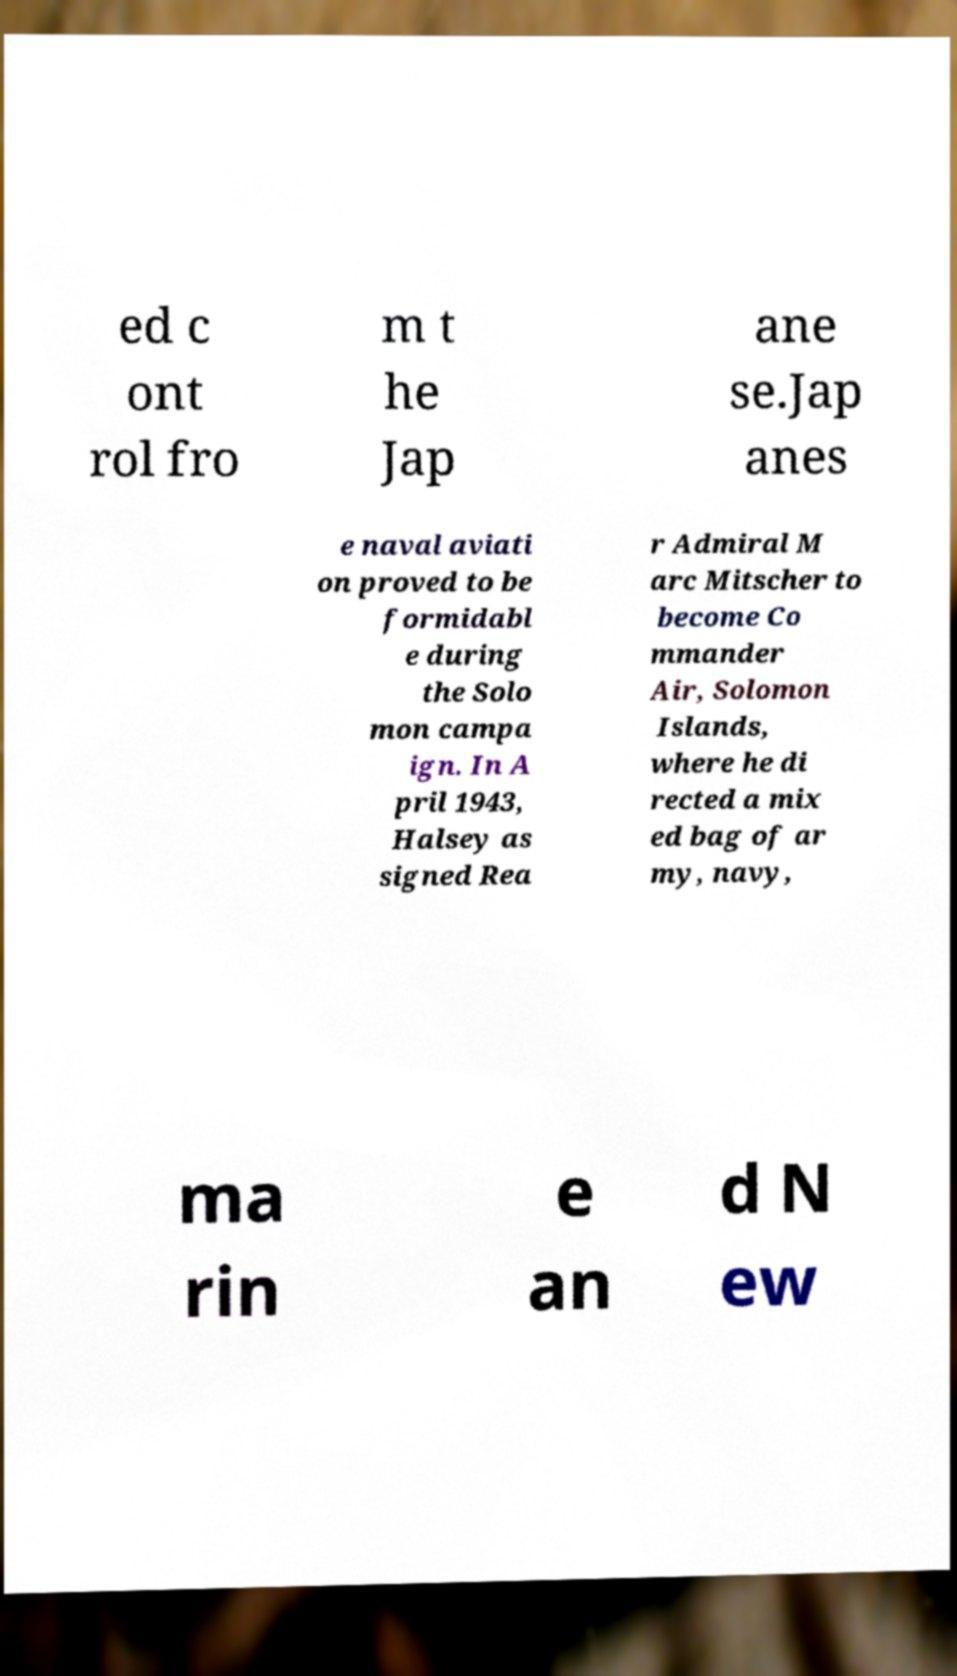I need the written content from this picture converted into text. Can you do that? ed c ont rol fro m t he Jap ane se.Jap anes e naval aviati on proved to be formidabl e during the Solo mon campa ign. In A pril 1943, Halsey as signed Rea r Admiral M arc Mitscher to become Co mmander Air, Solomon Islands, where he di rected a mix ed bag of ar my, navy, ma rin e an d N ew 